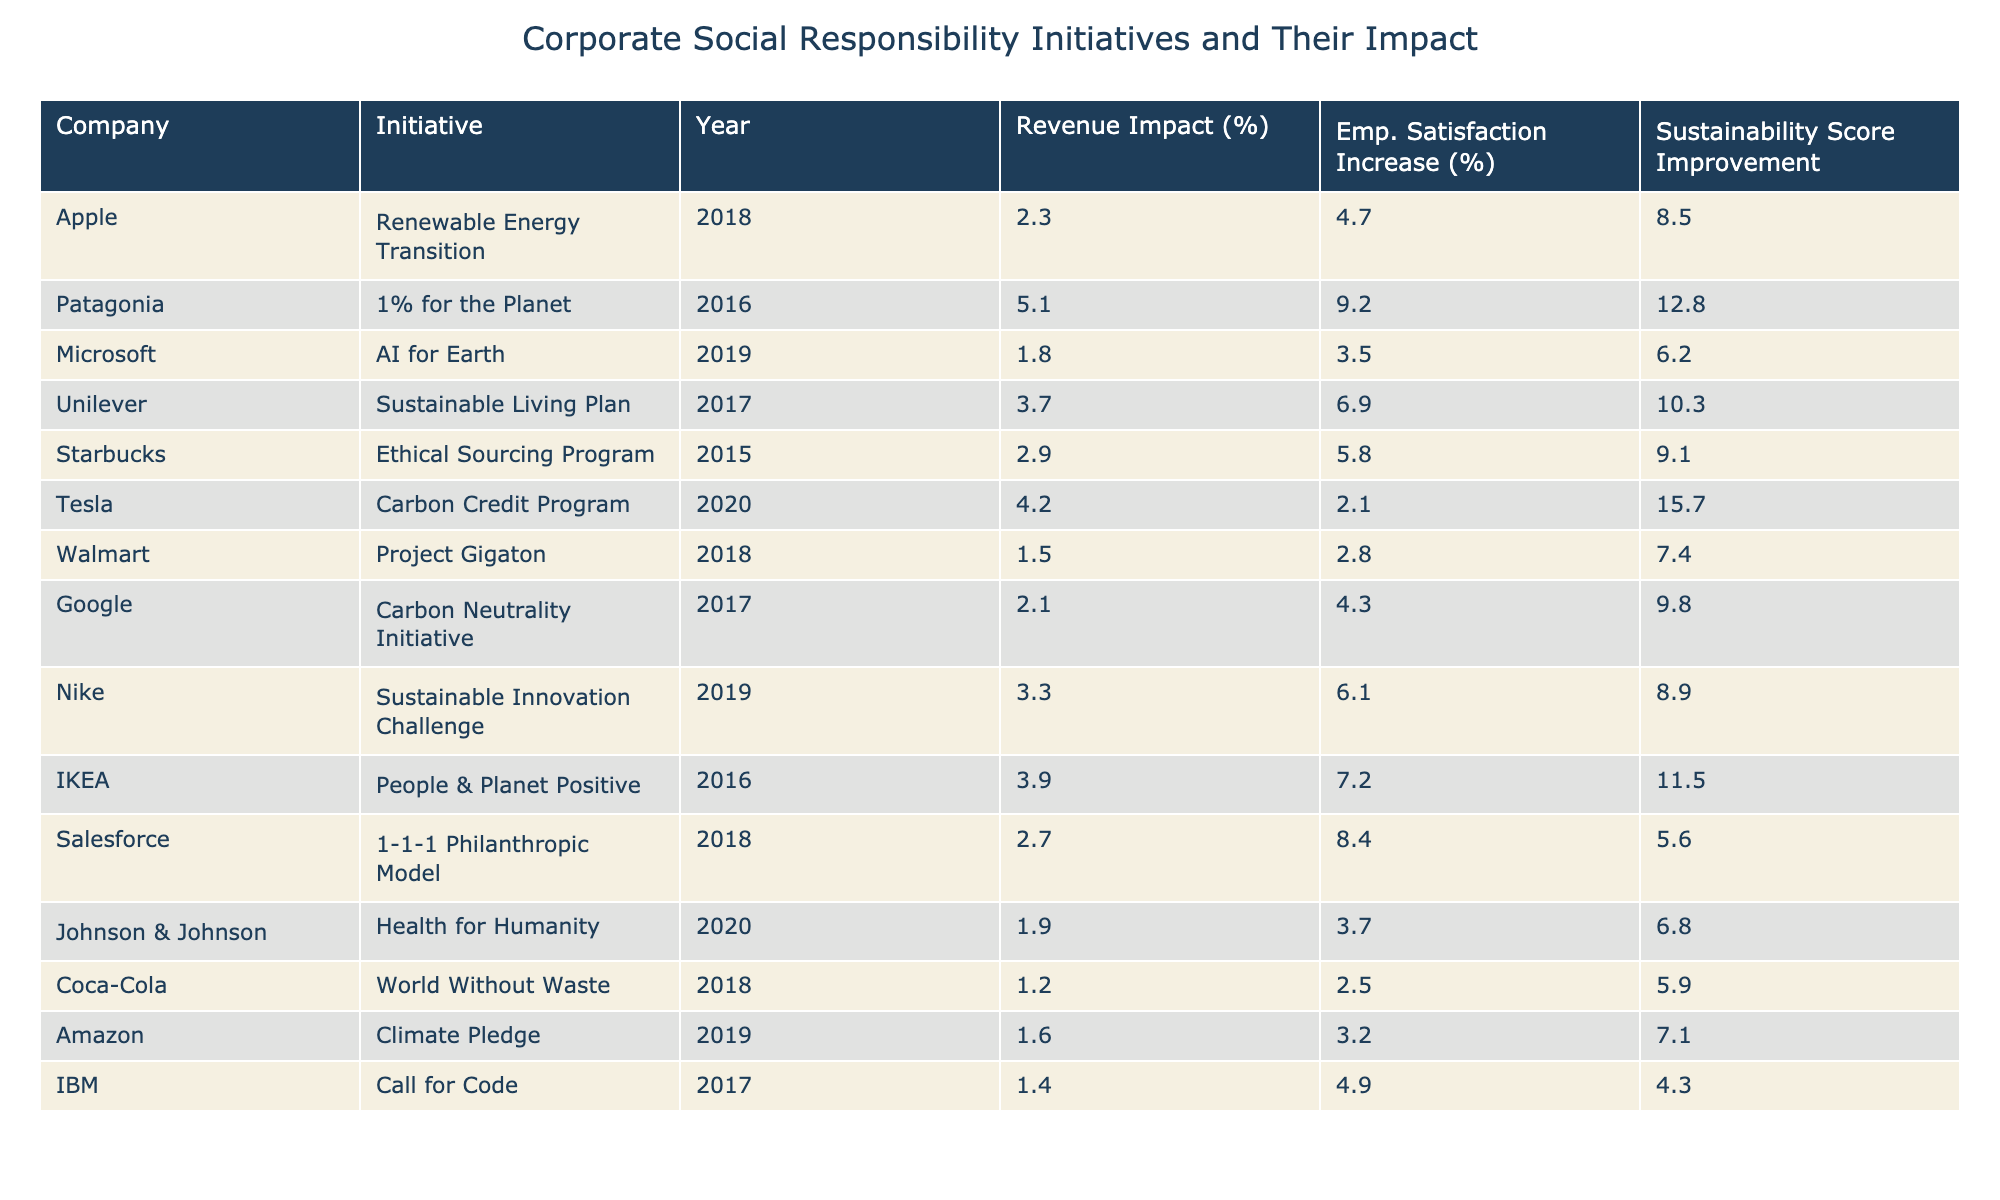What is the highest impact on revenue among the initiatives listed? Looking at the table, the initiative with the highest impact on revenue is Patagonia's "1% for the Planet," which shows a revenue impact of 5.1%.
Answer: 5.1% Which initiative resulted in the largest increase in employee satisfaction? By reviewing the "Employee Satisfaction Increase (%)" column, Patagonia's "1% for the Planet" also resulted in the largest increase in employee satisfaction at 9.2%.
Answer: 9.2% What is the average sustainability score improvement across all initiatives? To find the average, sum the sustainability score improvements (8.5 + 12.8 + 6.2 + 10.3 + 9.1 + 15.7 + 7.4 + 9.8 + 8.9 + 11.5 + 5.6 + 6.8 + 5.9 + 7.1 + 4.3) which equals 105.5, then divide by the number of initiatives (15), resulting in approximately 7.03.
Answer: 7.03 Which company initiated a program that improved sustainability score by over 15%? Checking the sustainability score improvement, Tesla's "Carbon Credit Program" shows an improvement of 15.7%, which is the only one over 15%.
Answer: Yes Is there any initiative that had a negative impact on employee satisfaction? By examining the "Employee Satisfaction Increase (%)" column, all initiatives display positive increases in employee satisfaction, with the lowest being Tesla at 2.1%. Therefore, there are no negative impacts.
Answer: No Which company's initiative had both a high revenue impact and a significant increase in employee satisfaction? The initiatives of Patagonia and IKEA had high revenue impacts (5.1% and 3.9%) with corresponding employee satisfaction increases (9.2% and 7.2%). Therefore, both meet the criteria for high revenue impact and significant employee satisfaction increase.
Answer: Patagonia and IKEA What is the total revenue impact percentage of all initiatives combined? To find the total, sum all revenue impact percentages (2.3 + 5.1 + 1.8 + 3.7 + 2.9 + 4.2 + 1.5 + 2.1 + 3.3 + 3.9 + 2.7 + 1.9 + 1.2 + 1.6 + 1.4), which equals 37.7%.
Answer: 37.7% Which initiative had the least impact on revenue? Checking the "Impact on Revenue (%)" column, Coca-Cola's "World Without Waste" had the least impact on revenue at 1.2%.
Answer: 1.2% How much more did Patagonia's initiative increase employee satisfaction compared to Coca-Cola's? The difference is calculated by subtracting Coca-Cola's increase (2.5%) from Patagonia's (9.2%), which results in 6.7%.
Answer: 6.7% What is the relationship between sustainability score improvement and employee satisfaction increase for IKEA? IKEA's initiative "People & Planet Positive" resulted in a sustainability score improvement of 11.5% and an employee satisfaction increase of 7.2%. This indicates a positive correlation, as both metrics are high.
Answer: Positive correlation 